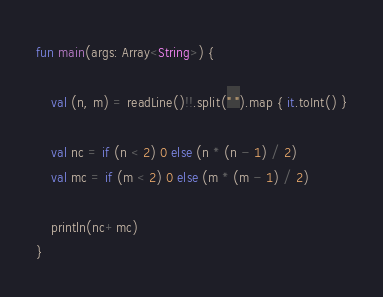<code> <loc_0><loc_0><loc_500><loc_500><_Kotlin_>fun main(args: Array<String>) {

    val (n, m) = readLine()!!.split(" ").map { it.toInt() }

    val nc = if (n < 2) 0 else (n * (n - 1) / 2)
    val mc = if (m < 2) 0 else (m * (m - 1) / 2)

    println(nc+mc)
}</code> 